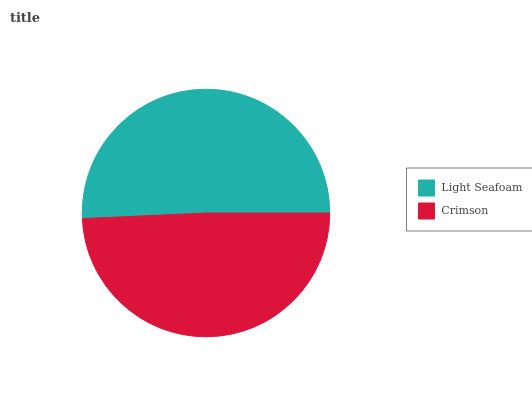Is Crimson the minimum?
Answer yes or no. Yes. Is Light Seafoam the maximum?
Answer yes or no. Yes. Is Crimson the maximum?
Answer yes or no. No. Is Light Seafoam greater than Crimson?
Answer yes or no. Yes. Is Crimson less than Light Seafoam?
Answer yes or no. Yes. Is Crimson greater than Light Seafoam?
Answer yes or no. No. Is Light Seafoam less than Crimson?
Answer yes or no. No. Is Light Seafoam the high median?
Answer yes or no. Yes. Is Crimson the low median?
Answer yes or no. Yes. Is Crimson the high median?
Answer yes or no. No. Is Light Seafoam the low median?
Answer yes or no. No. 